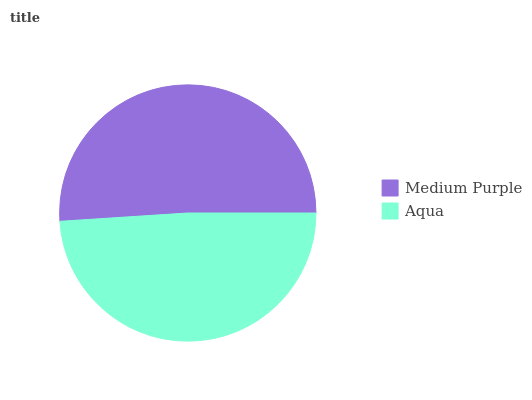Is Aqua the minimum?
Answer yes or no. Yes. Is Medium Purple the maximum?
Answer yes or no. Yes. Is Aqua the maximum?
Answer yes or no. No. Is Medium Purple greater than Aqua?
Answer yes or no. Yes. Is Aqua less than Medium Purple?
Answer yes or no. Yes. Is Aqua greater than Medium Purple?
Answer yes or no. No. Is Medium Purple less than Aqua?
Answer yes or no. No. Is Medium Purple the high median?
Answer yes or no. Yes. Is Aqua the low median?
Answer yes or no. Yes. Is Aqua the high median?
Answer yes or no. No. Is Medium Purple the low median?
Answer yes or no. No. 